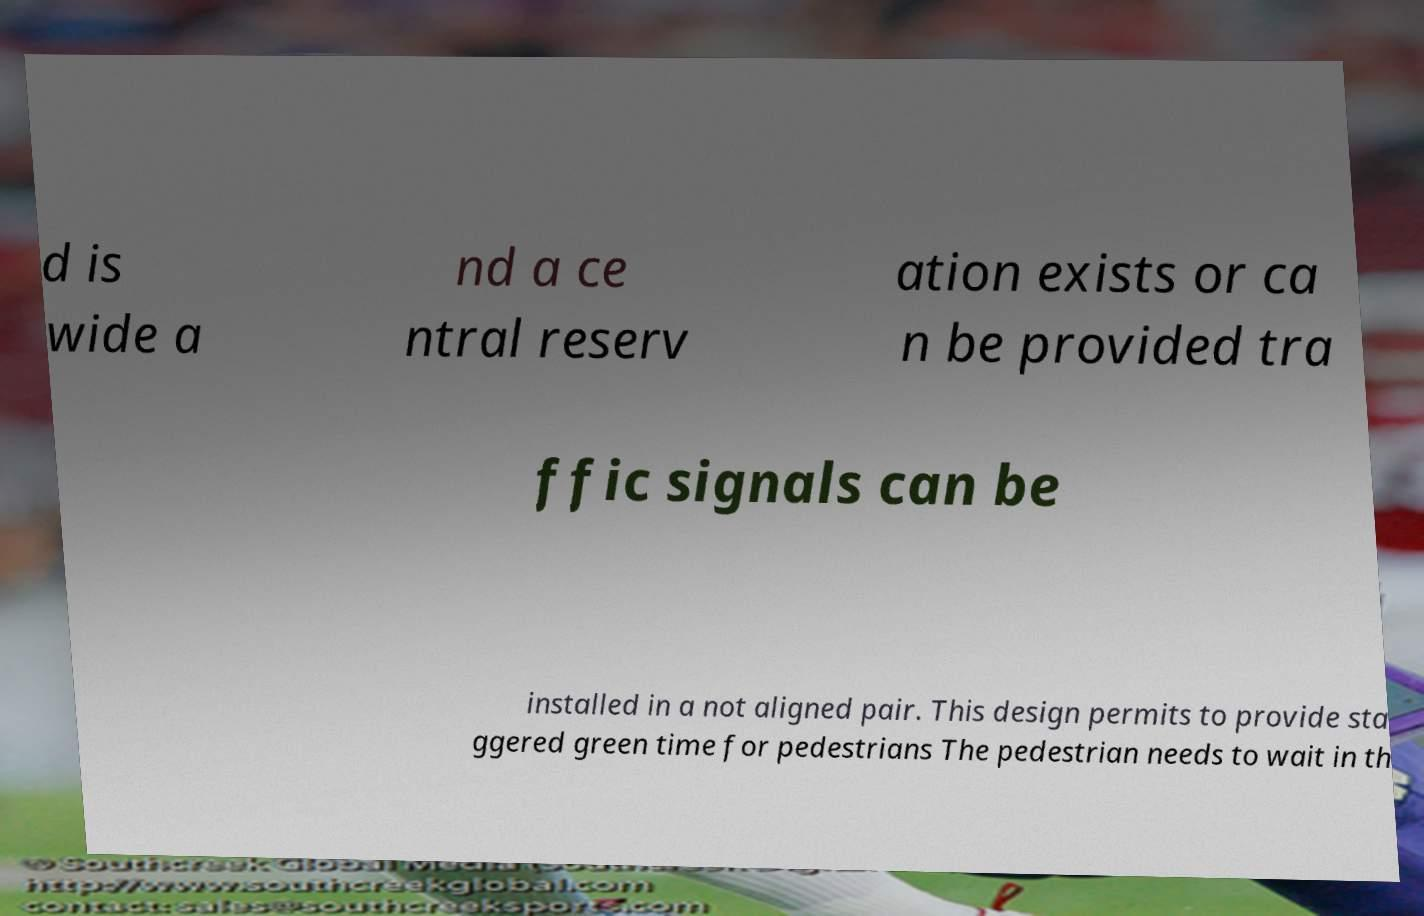What messages or text are displayed in this image? I need them in a readable, typed format. d is wide a nd a ce ntral reserv ation exists or ca n be provided tra ffic signals can be installed in a not aligned pair. This design permits to provide sta ggered green time for pedestrians The pedestrian needs to wait in th 